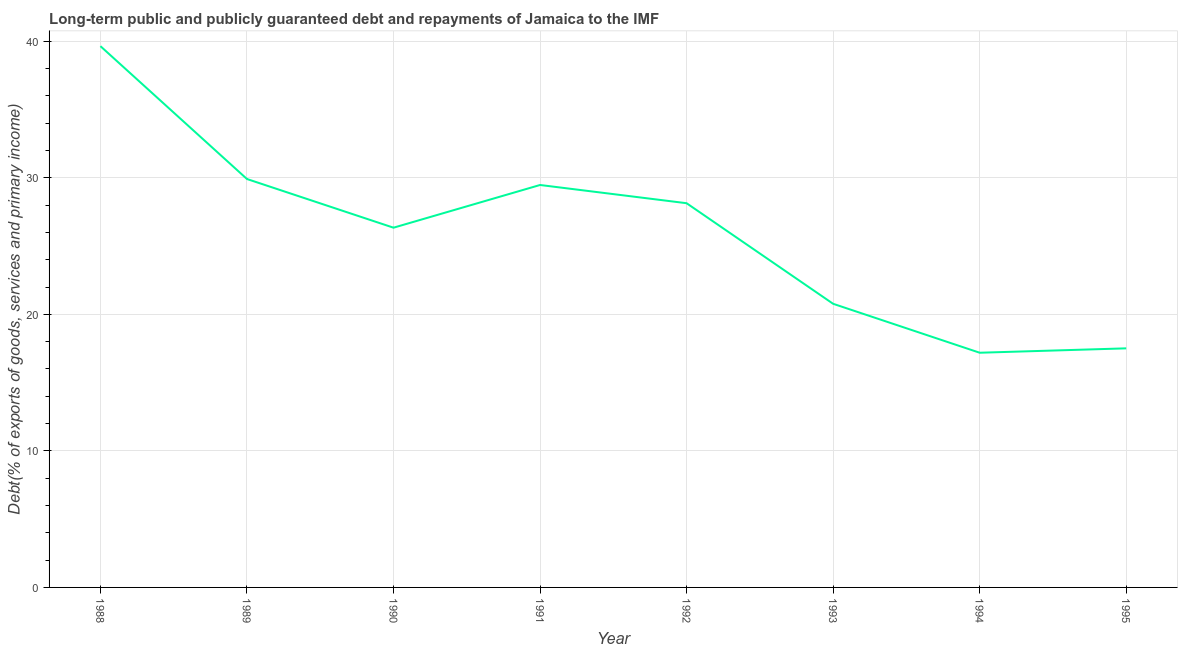What is the debt service in 1993?
Your answer should be compact. 20.78. Across all years, what is the maximum debt service?
Keep it short and to the point. 39.65. Across all years, what is the minimum debt service?
Keep it short and to the point. 17.19. In which year was the debt service minimum?
Make the answer very short. 1994. What is the sum of the debt service?
Your answer should be compact. 209.01. What is the difference between the debt service in 1994 and 1995?
Your answer should be very brief. -0.32. What is the average debt service per year?
Your response must be concise. 26.13. What is the median debt service?
Make the answer very short. 27.25. In how many years, is the debt service greater than 22 %?
Your answer should be very brief. 5. What is the ratio of the debt service in 1991 to that in 1995?
Make the answer very short. 1.68. Is the difference between the debt service in 1988 and 1990 greater than the difference between any two years?
Your response must be concise. No. What is the difference between the highest and the second highest debt service?
Provide a short and direct response. 9.73. Is the sum of the debt service in 1989 and 1993 greater than the maximum debt service across all years?
Keep it short and to the point. Yes. What is the difference between the highest and the lowest debt service?
Ensure brevity in your answer.  22.46. In how many years, is the debt service greater than the average debt service taken over all years?
Your answer should be compact. 5. Does the debt service monotonically increase over the years?
Keep it short and to the point. No. How many lines are there?
Ensure brevity in your answer.  1. What is the difference between two consecutive major ticks on the Y-axis?
Your answer should be very brief. 10. Are the values on the major ticks of Y-axis written in scientific E-notation?
Make the answer very short. No. Does the graph contain grids?
Give a very brief answer. Yes. What is the title of the graph?
Offer a terse response. Long-term public and publicly guaranteed debt and repayments of Jamaica to the IMF. What is the label or title of the X-axis?
Your answer should be very brief. Year. What is the label or title of the Y-axis?
Offer a terse response. Debt(% of exports of goods, services and primary income). What is the Debt(% of exports of goods, services and primary income) of 1988?
Your answer should be very brief. 39.65. What is the Debt(% of exports of goods, services and primary income) in 1989?
Offer a very short reply. 29.92. What is the Debt(% of exports of goods, services and primary income) of 1990?
Provide a succinct answer. 26.35. What is the Debt(% of exports of goods, services and primary income) in 1991?
Your response must be concise. 29.48. What is the Debt(% of exports of goods, services and primary income) in 1992?
Offer a terse response. 28.14. What is the Debt(% of exports of goods, services and primary income) of 1993?
Give a very brief answer. 20.78. What is the Debt(% of exports of goods, services and primary income) in 1994?
Keep it short and to the point. 17.19. What is the Debt(% of exports of goods, services and primary income) of 1995?
Keep it short and to the point. 17.51. What is the difference between the Debt(% of exports of goods, services and primary income) in 1988 and 1989?
Provide a succinct answer. 9.73. What is the difference between the Debt(% of exports of goods, services and primary income) in 1988 and 1990?
Your answer should be compact. 13.3. What is the difference between the Debt(% of exports of goods, services and primary income) in 1988 and 1991?
Your answer should be very brief. 10.17. What is the difference between the Debt(% of exports of goods, services and primary income) in 1988 and 1992?
Give a very brief answer. 11.5. What is the difference between the Debt(% of exports of goods, services and primary income) in 1988 and 1993?
Your answer should be compact. 18.87. What is the difference between the Debt(% of exports of goods, services and primary income) in 1988 and 1994?
Ensure brevity in your answer.  22.46. What is the difference between the Debt(% of exports of goods, services and primary income) in 1988 and 1995?
Your answer should be very brief. 22.14. What is the difference between the Debt(% of exports of goods, services and primary income) in 1989 and 1990?
Make the answer very short. 3.57. What is the difference between the Debt(% of exports of goods, services and primary income) in 1989 and 1991?
Provide a succinct answer. 0.44. What is the difference between the Debt(% of exports of goods, services and primary income) in 1989 and 1992?
Provide a short and direct response. 1.77. What is the difference between the Debt(% of exports of goods, services and primary income) in 1989 and 1993?
Offer a very short reply. 9.14. What is the difference between the Debt(% of exports of goods, services and primary income) in 1989 and 1994?
Provide a short and direct response. 12.72. What is the difference between the Debt(% of exports of goods, services and primary income) in 1989 and 1995?
Give a very brief answer. 12.4. What is the difference between the Debt(% of exports of goods, services and primary income) in 1990 and 1991?
Provide a short and direct response. -3.13. What is the difference between the Debt(% of exports of goods, services and primary income) in 1990 and 1992?
Give a very brief answer. -1.79. What is the difference between the Debt(% of exports of goods, services and primary income) in 1990 and 1993?
Your answer should be very brief. 5.57. What is the difference between the Debt(% of exports of goods, services and primary income) in 1990 and 1994?
Provide a succinct answer. 9.16. What is the difference between the Debt(% of exports of goods, services and primary income) in 1990 and 1995?
Ensure brevity in your answer.  8.84. What is the difference between the Debt(% of exports of goods, services and primary income) in 1991 and 1992?
Keep it short and to the point. 1.33. What is the difference between the Debt(% of exports of goods, services and primary income) in 1991 and 1993?
Provide a short and direct response. 8.7. What is the difference between the Debt(% of exports of goods, services and primary income) in 1991 and 1994?
Your response must be concise. 12.29. What is the difference between the Debt(% of exports of goods, services and primary income) in 1991 and 1995?
Ensure brevity in your answer.  11.97. What is the difference between the Debt(% of exports of goods, services and primary income) in 1992 and 1993?
Your answer should be compact. 7.37. What is the difference between the Debt(% of exports of goods, services and primary income) in 1992 and 1994?
Provide a short and direct response. 10.95. What is the difference between the Debt(% of exports of goods, services and primary income) in 1992 and 1995?
Ensure brevity in your answer.  10.63. What is the difference between the Debt(% of exports of goods, services and primary income) in 1993 and 1994?
Offer a very short reply. 3.58. What is the difference between the Debt(% of exports of goods, services and primary income) in 1993 and 1995?
Offer a very short reply. 3.26. What is the difference between the Debt(% of exports of goods, services and primary income) in 1994 and 1995?
Ensure brevity in your answer.  -0.32. What is the ratio of the Debt(% of exports of goods, services and primary income) in 1988 to that in 1989?
Ensure brevity in your answer.  1.32. What is the ratio of the Debt(% of exports of goods, services and primary income) in 1988 to that in 1990?
Keep it short and to the point. 1.5. What is the ratio of the Debt(% of exports of goods, services and primary income) in 1988 to that in 1991?
Your answer should be very brief. 1.34. What is the ratio of the Debt(% of exports of goods, services and primary income) in 1988 to that in 1992?
Give a very brief answer. 1.41. What is the ratio of the Debt(% of exports of goods, services and primary income) in 1988 to that in 1993?
Provide a short and direct response. 1.91. What is the ratio of the Debt(% of exports of goods, services and primary income) in 1988 to that in 1994?
Offer a terse response. 2.31. What is the ratio of the Debt(% of exports of goods, services and primary income) in 1988 to that in 1995?
Give a very brief answer. 2.26. What is the ratio of the Debt(% of exports of goods, services and primary income) in 1989 to that in 1990?
Make the answer very short. 1.14. What is the ratio of the Debt(% of exports of goods, services and primary income) in 1989 to that in 1992?
Offer a terse response. 1.06. What is the ratio of the Debt(% of exports of goods, services and primary income) in 1989 to that in 1993?
Make the answer very short. 1.44. What is the ratio of the Debt(% of exports of goods, services and primary income) in 1989 to that in 1994?
Ensure brevity in your answer.  1.74. What is the ratio of the Debt(% of exports of goods, services and primary income) in 1989 to that in 1995?
Your response must be concise. 1.71. What is the ratio of the Debt(% of exports of goods, services and primary income) in 1990 to that in 1991?
Offer a terse response. 0.89. What is the ratio of the Debt(% of exports of goods, services and primary income) in 1990 to that in 1992?
Ensure brevity in your answer.  0.94. What is the ratio of the Debt(% of exports of goods, services and primary income) in 1990 to that in 1993?
Your response must be concise. 1.27. What is the ratio of the Debt(% of exports of goods, services and primary income) in 1990 to that in 1994?
Make the answer very short. 1.53. What is the ratio of the Debt(% of exports of goods, services and primary income) in 1990 to that in 1995?
Ensure brevity in your answer.  1.5. What is the ratio of the Debt(% of exports of goods, services and primary income) in 1991 to that in 1992?
Provide a short and direct response. 1.05. What is the ratio of the Debt(% of exports of goods, services and primary income) in 1991 to that in 1993?
Offer a terse response. 1.42. What is the ratio of the Debt(% of exports of goods, services and primary income) in 1991 to that in 1994?
Provide a short and direct response. 1.72. What is the ratio of the Debt(% of exports of goods, services and primary income) in 1991 to that in 1995?
Provide a short and direct response. 1.68. What is the ratio of the Debt(% of exports of goods, services and primary income) in 1992 to that in 1993?
Your answer should be compact. 1.35. What is the ratio of the Debt(% of exports of goods, services and primary income) in 1992 to that in 1994?
Make the answer very short. 1.64. What is the ratio of the Debt(% of exports of goods, services and primary income) in 1992 to that in 1995?
Provide a succinct answer. 1.61. What is the ratio of the Debt(% of exports of goods, services and primary income) in 1993 to that in 1994?
Offer a very short reply. 1.21. What is the ratio of the Debt(% of exports of goods, services and primary income) in 1993 to that in 1995?
Your answer should be compact. 1.19. 